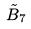<formula> <loc_0><loc_0><loc_500><loc_500>\tilde { B } _ { 7 }</formula> 